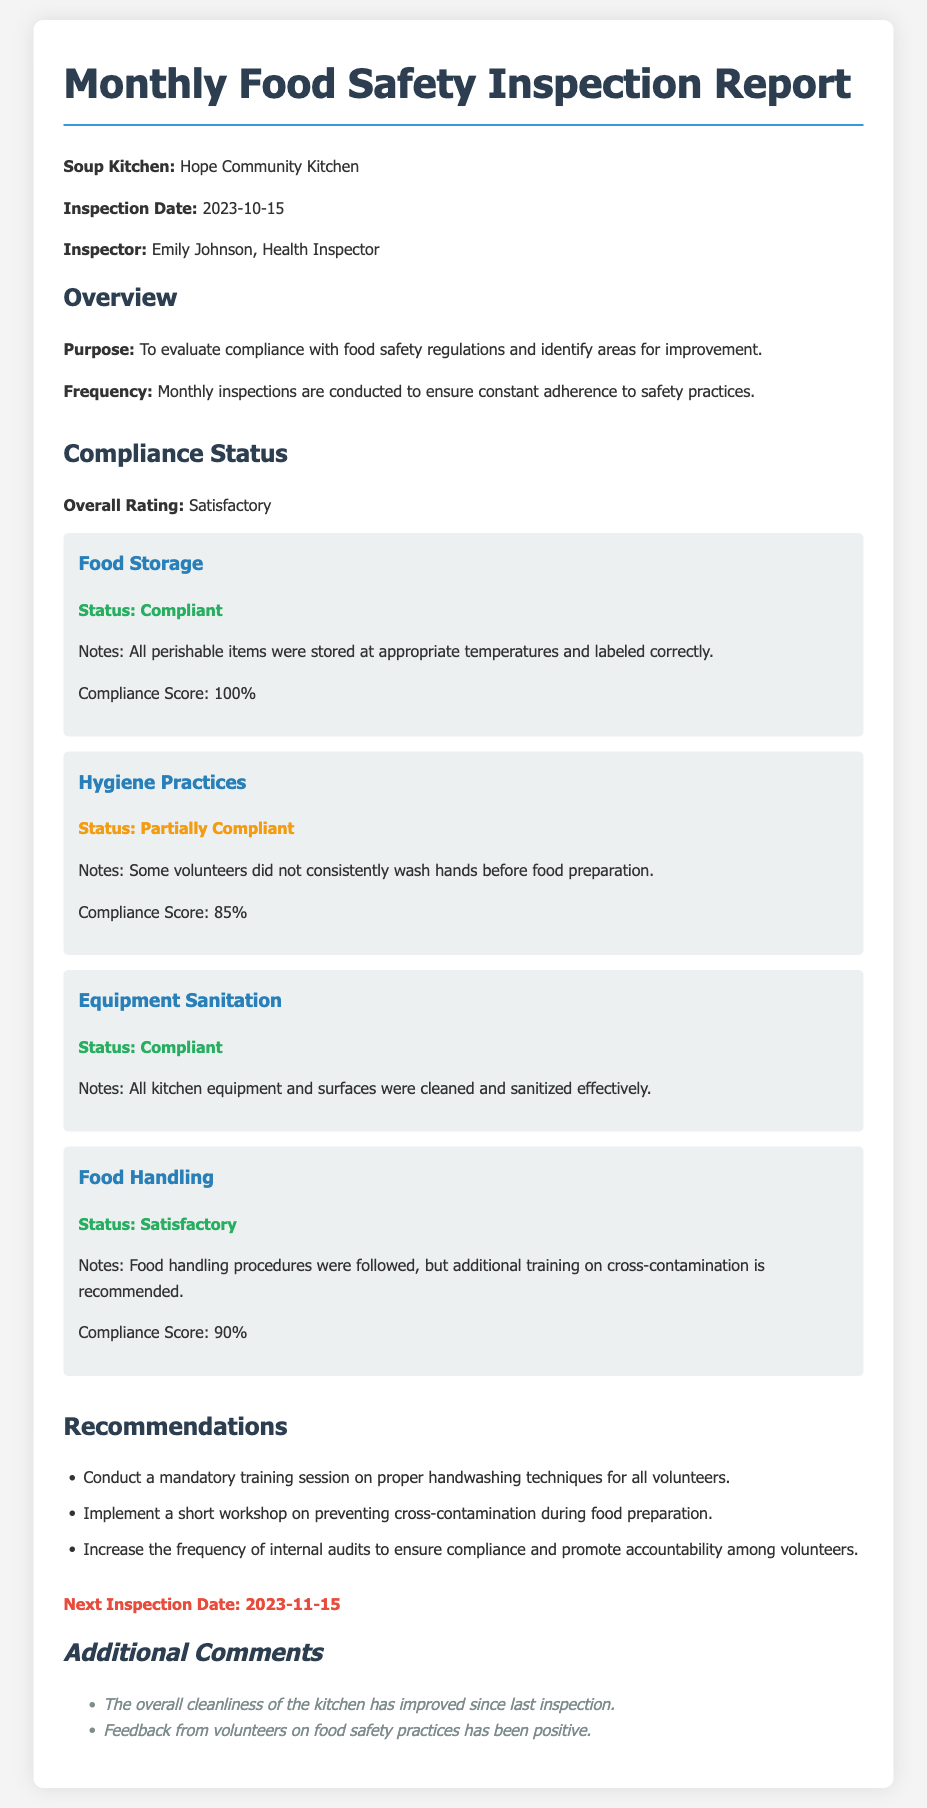What is the name of the soup kitchen? The name of the soup kitchen is provided in the document, under the Soup Kitchen section.
Answer: Hope Community Kitchen Who conducted the inspection? The document lists the inspector's name under the Inspector section.
Answer: Emily Johnson What was the overall compliance rating? This rating is stated explicitly in the Compliance Status section of the document.
Answer: Satisfactory What is the status of food storage compliance? The status regarding food storage compliance is mentioned under the Food Storage area.
Answer: Compliant What is one of the recommendations given? Recommendations are listed in the Recommendations section, and this asks for any specific one.
Answer: Conduct a mandatory training session on proper handwashing techniques for all volunteers What is the compliance score for hygiene practices? This score is provided in the Hygiene Practices area, indicating the level of compliance.
Answer: 85% What date is the next inspection scheduled for? The next inspection date is mentioned at the end of the document.
Answer: 2023-11-15 What improvement was noted in the additional comments? The document specifies improvements or remarks in the Additional Comments section.
Answer: The overall cleanliness of the kitchen has improved since last inspection 